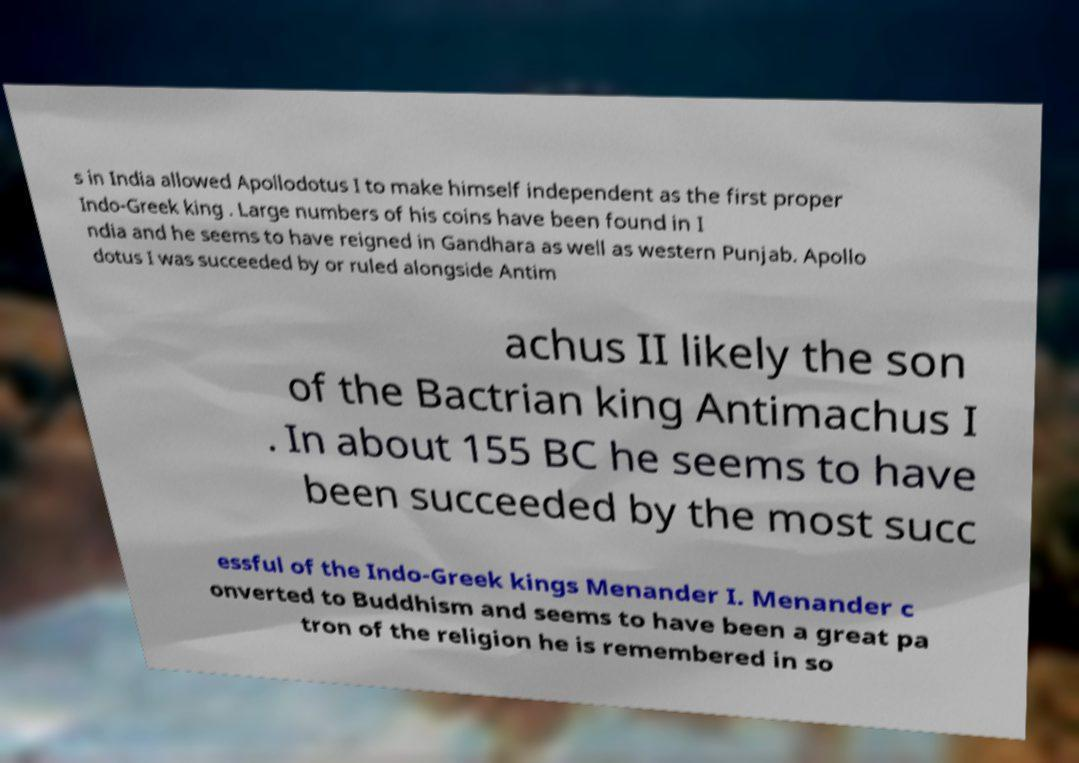There's text embedded in this image that I need extracted. Can you transcribe it verbatim? s in India allowed Apollodotus I to make himself independent as the first proper Indo-Greek king . Large numbers of his coins have been found in I ndia and he seems to have reigned in Gandhara as well as western Punjab. Apollo dotus I was succeeded by or ruled alongside Antim achus II likely the son of the Bactrian king Antimachus I . In about 155 BC he seems to have been succeeded by the most succ essful of the Indo-Greek kings Menander I. Menander c onverted to Buddhism and seems to have been a great pa tron of the religion he is remembered in so 